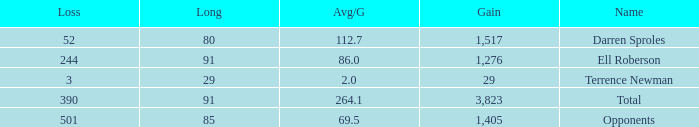When the player gained below 1,405 yards and lost over 390 yards, what's the sum of the long yards? None. 